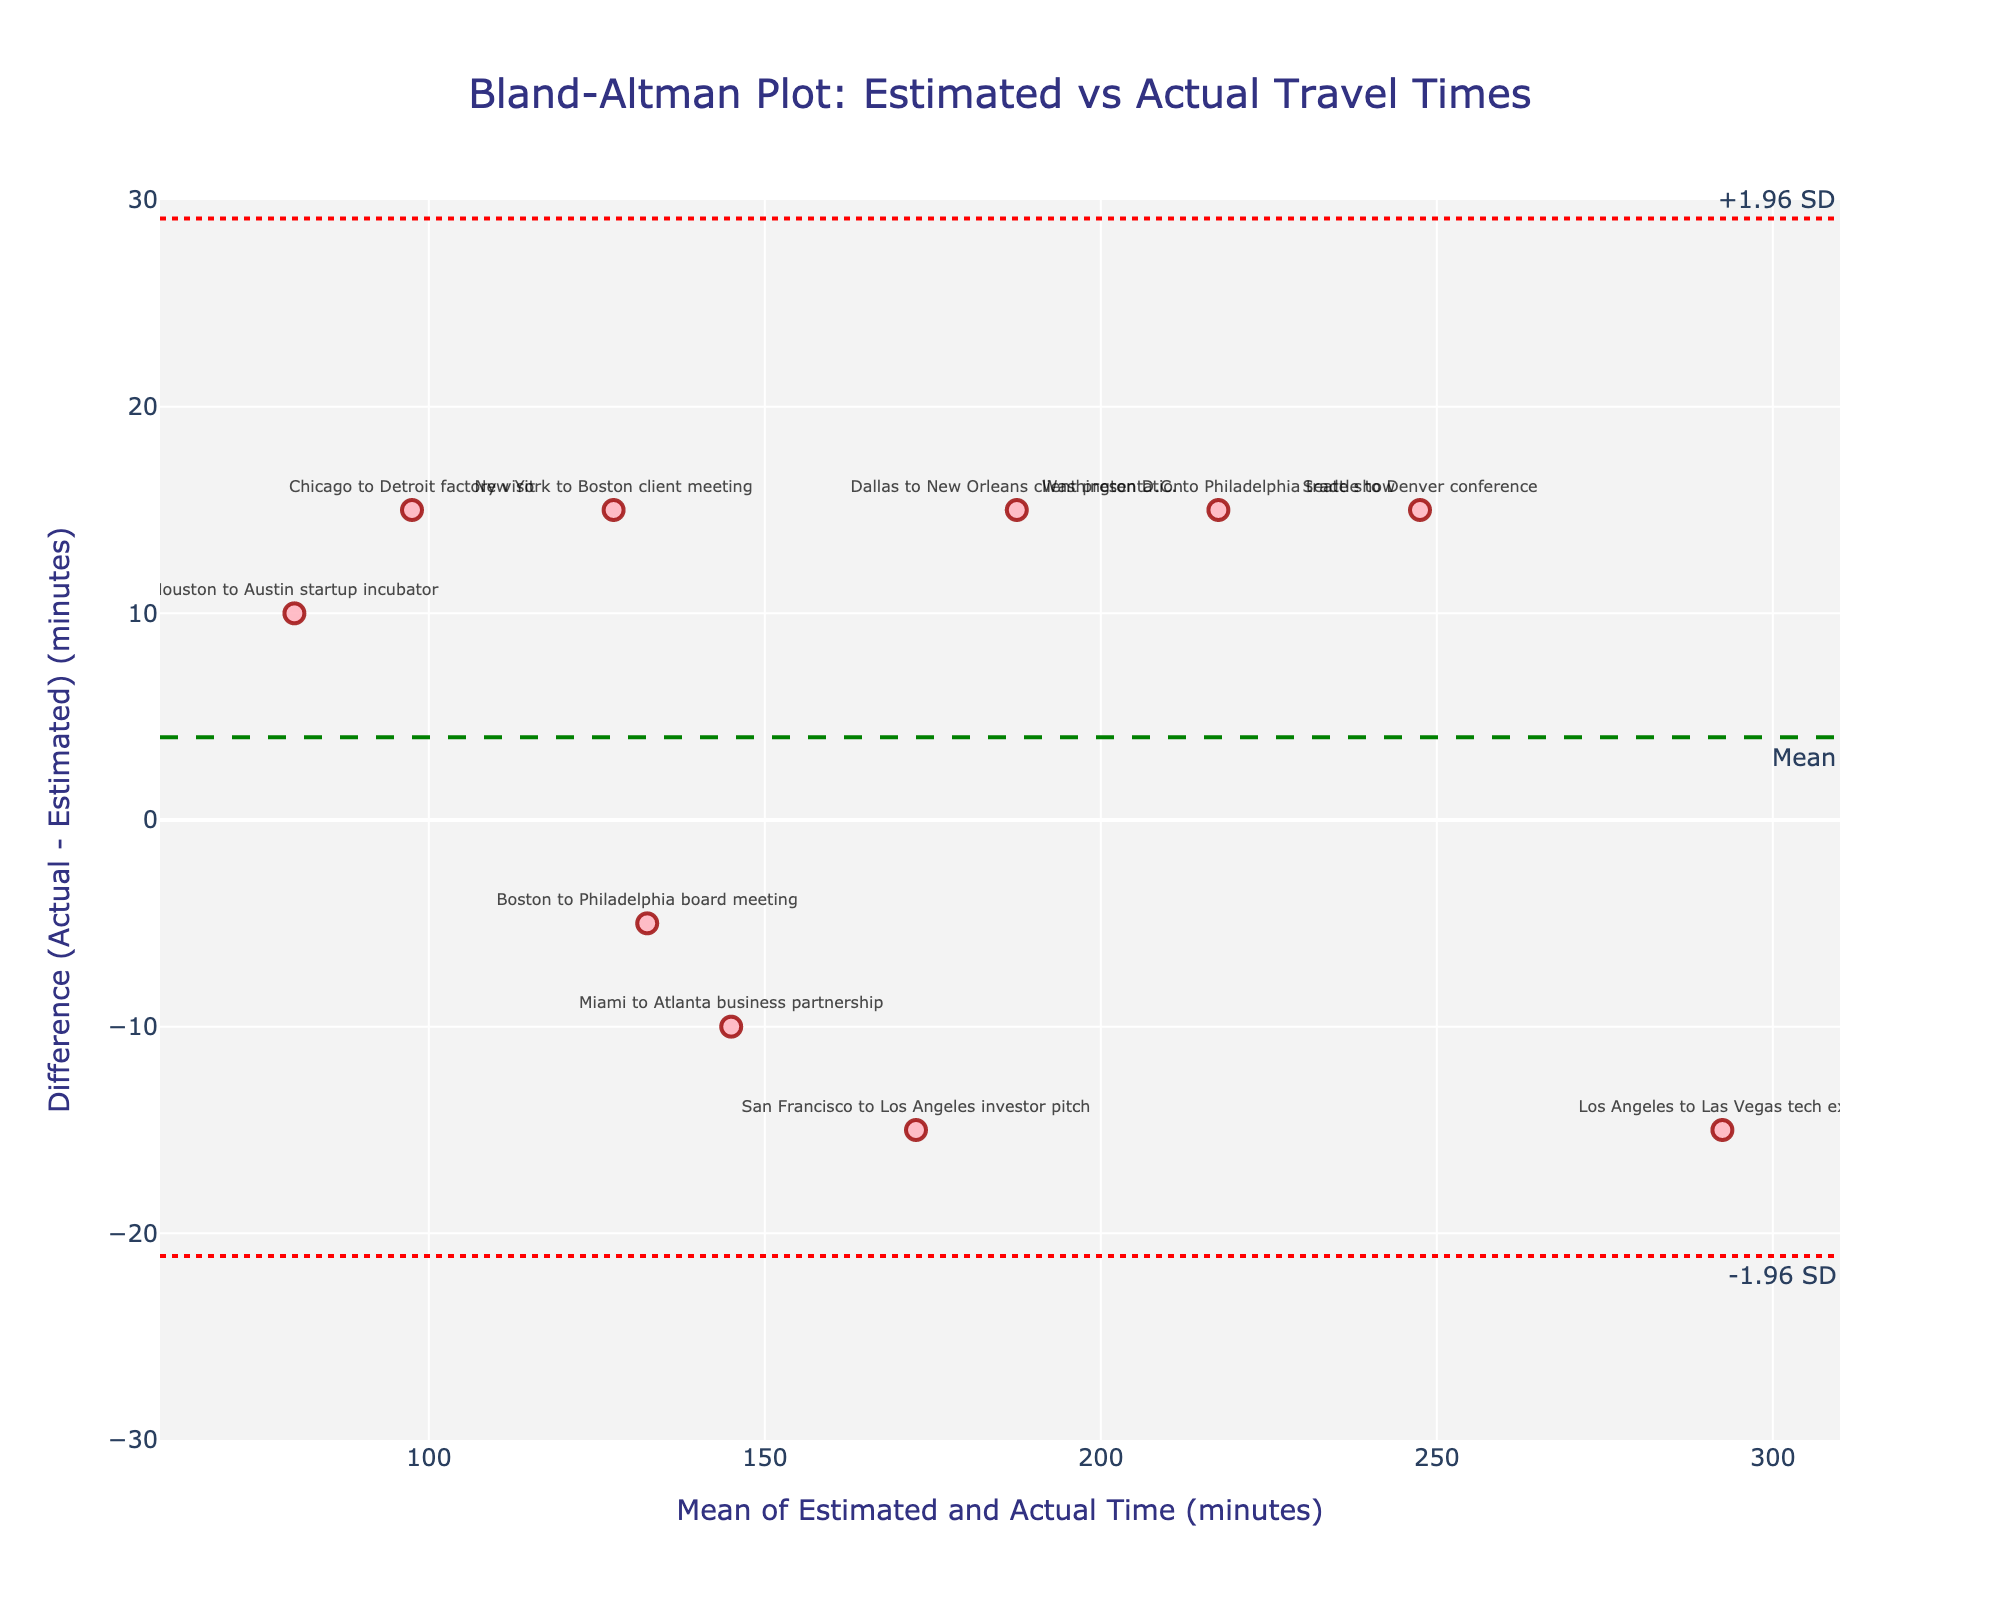What is the title of the Bland-Altman plot? The title of a plot often provides a brief description of what the plot represents. By looking at the top of the plot, you can see the title clearly displayed.
Answer: Bland-Altman Plot: Estimated vs Actual Travel Times What is the range of the x-axis? The x-axis represents the mean of estimated and actual travel times and the range can be determined by looking at the axis labels at the bottom of the plot.
Answer: 60 to 310 minutes What does the green dashed line represent? The green dashed line indicates the mean difference between the actual and estimated travel times. This value is calculated as the average of all differences (Actual - Estimated).
Answer: Mean difference How many data points are represented in the plot? Each marker on the plot represents a data point. Counting these markers will give the total number of data points displayed.
Answer: 10 data points What does a red dotted line above the green dashed line signify? The red dotted line above the green dashed line represents the upper limit of agreement, which is the mean difference plus 1.96 times the standard deviation of the differences.
Answer: +1.96 SD What trip has the smallest difference between actual and estimated times and what is its value? The trip with the smallest difference will be the one closest to zero on the y-axis. By checking the values, "Boston to Philadelphia" stands out as having a difference close to zero.
Answer: Boston to Philadelphia, 5 minutes What is the mean of the estimated and actual travel times for the Dallas to New Orleans trip? To find the mean of the estimated and actual travel times, we add them together and divide by 2. For Dallas to New Orleans: (180 + 195) / 2.
Answer: 187.5 minutes Which trip has the largest positive difference and what is its value? The largest positive difference is represented by the highest point above the green dashed line on the y-axis. By checking the values, the "Chicago to Detroit" trip has the largest positive difference.
Answer: Chicago to Detroit, 15 minutes What are the lower and upper limits of agreement? The limits of agreement are determined by the mean difference plus and minus 1.96 times the standard deviation of the differences. These values are found at the red dotted lines.
Answer: -21.99 to 21.99 minutes How many trips have actual travel times longer than the estimated times? Trips with actual travel times longer than estimated will have positive differences, i.e., above the green dashed line. Count these specific data points.
Answer: 6 trips 